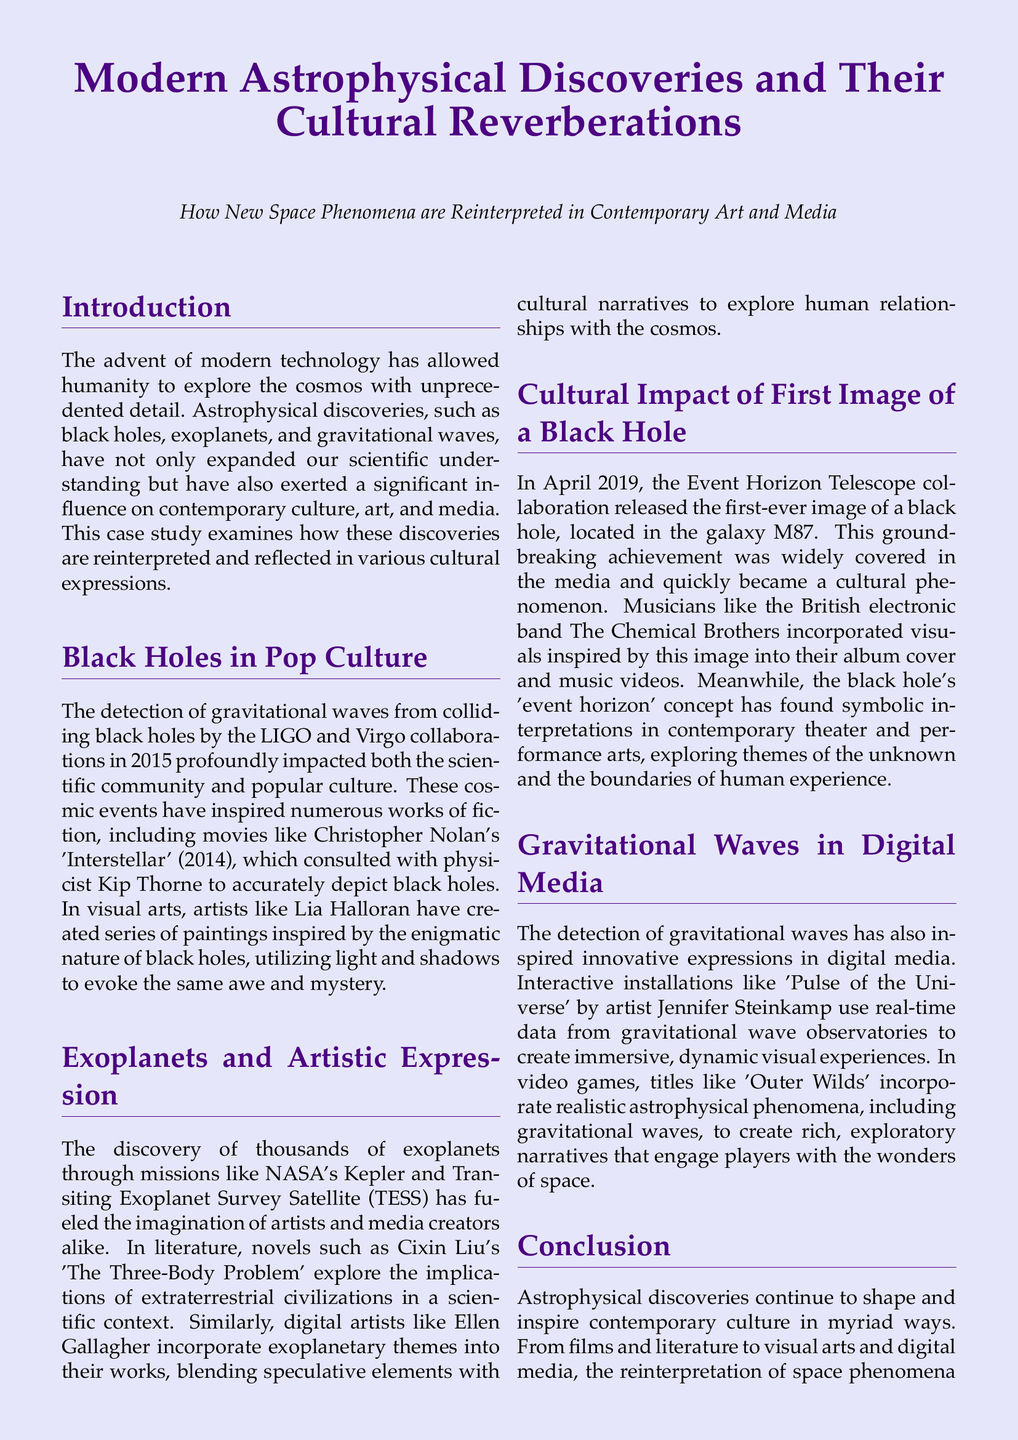What significant astrophysical discovery was made in 2015? The document states that the detection of gravitational waves from colliding black holes was a major discovery made in 2015.
Answer: gravitational waves Who consulted on the movie 'Interstellar' to depict black holes accurately? The document mentions that physicist Kip Thorne consulted on the movie to ensure accurate depiction of black holes.
Answer: Kip Thorne What artistic medium did Lia Halloran use to interpret black holes? According to the document, Lia Halloran created a series of paintings inspired by black holes.
Answer: paintings What is the title of Cixin Liu's novel that explores extraterrestrial civilizations? The document refers to Cixin Liu's novel 'The Three-Body Problem' as exploring extraterrestrial civilizations.
Answer: The Three-Body Problem What year was the first image of a black hole released? The document states that the first-ever image of a black hole was released in April 2019.
Answer: April 2019 What band incorporated visuals inspired by the first black hole image into their music? The document notes that the British electronic band The Chemical Brothers used visuals inspired by the black hole image.
Answer: The Chemical Brothers What concept from the black hole's image is explored in contemporary theater? The document mentions that the concept of the black hole's 'event horizon' has found symbolic interpretations in theater.
Answer: event horizon What is the name of the interactive installation by Jennifer Steinkamp? The document specifies the installation as 'Pulse of the Universe.'
Answer: Pulse of the Universe Which video game incorporates realistic astrophysical phenomena, including gravitational waves? The document highlights 'Outer Wilds' as a video game that incorporates these phenomena.
Answer: Outer Wilds 